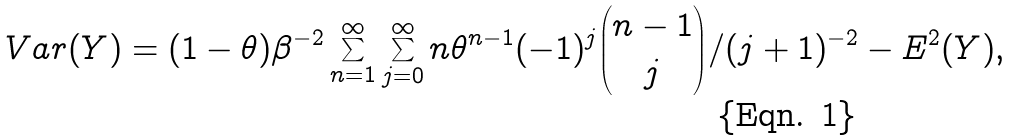Convert formula to latex. <formula><loc_0><loc_0><loc_500><loc_500>V a r ( Y ) = ( 1 - \theta ) \beta ^ { - 2 } \sum ^ { \infty } _ { n = 1 } \sum ^ { \infty } _ { j = 0 } n \theta ^ { n - 1 } ( - 1 ) ^ { j } { n - 1 \choose j } / ( j + 1 ) ^ { - 2 } - E ^ { 2 } ( Y ) ,</formula> 